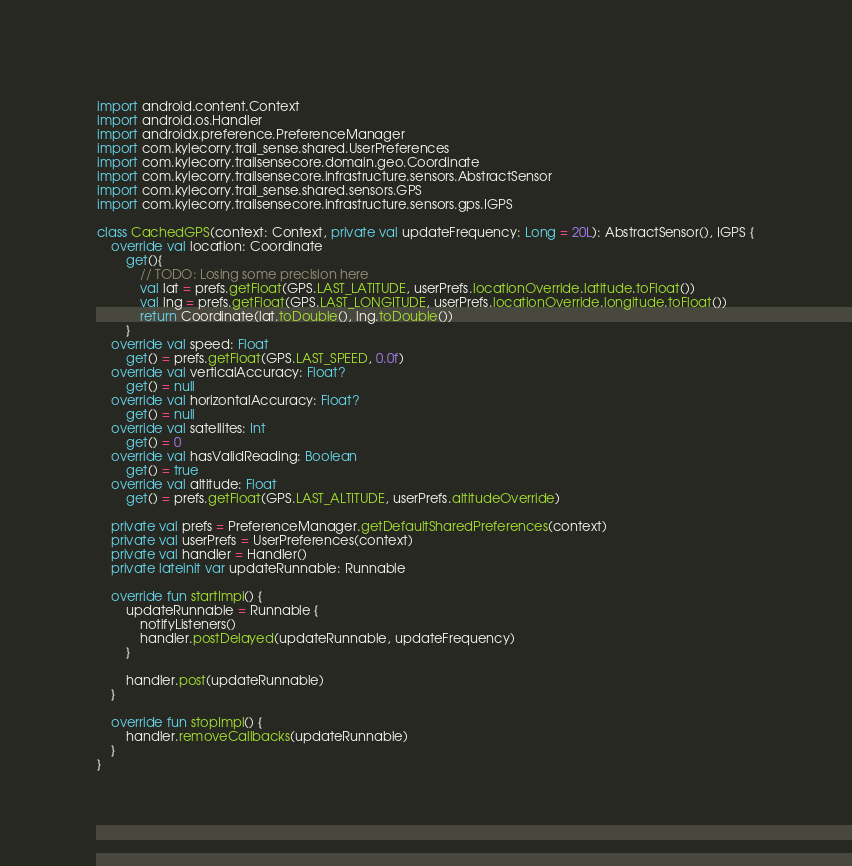<code> <loc_0><loc_0><loc_500><loc_500><_Kotlin_>import android.content.Context
import android.os.Handler
import androidx.preference.PreferenceManager
import com.kylecorry.trail_sense.shared.UserPreferences
import com.kylecorry.trailsensecore.domain.geo.Coordinate
import com.kylecorry.trailsensecore.infrastructure.sensors.AbstractSensor
import com.kylecorry.trail_sense.shared.sensors.GPS
import com.kylecorry.trailsensecore.infrastructure.sensors.gps.IGPS

class CachedGPS(context: Context, private val updateFrequency: Long = 20L): AbstractSensor(), IGPS {
    override val location: Coordinate
        get(){
            // TODO: Losing some precision here
            val lat = prefs.getFloat(GPS.LAST_LATITUDE, userPrefs.locationOverride.latitude.toFloat())
            val lng = prefs.getFloat(GPS.LAST_LONGITUDE, userPrefs.locationOverride.longitude.toFloat())
            return Coordinate(lat.toDouble(), lng.toDouble())
        }
    override val speed: Float
        get() = prefs.getFloat(GPS.LAST_SPEED, 0.0f)
    override val verticalAccuracy: Float?
        get() = null
    override val horizontalAccuracy: Float?
        get() = null
    override val satellites: Int
        get() = 0
    override val hasValidReading: Boolean
        get() = true
    override val altitude: Float
        get() = prefs.getFloat(GPS.LAST_ALTITUDE, userPrefs.altitudeOverride)

    private val prefs = PreferenceManager.getDefaultSharedPreferences(context)
    private val userPrefs = UserPreferences(context)
    private val handler = Handler()
    private lateinit var updateRunnable: Runnable

    override fun startImpl() {
        updateRunnable = Runnable {
            notifyListeners()
            handler.postDelayed(updateRunnable, updateFrequency)
        }

        handler.post(updateRunnable)
    }

    override fun stopImpl() {
        handler.removeCallbacks(updateRunnable)
    }
}</code> 